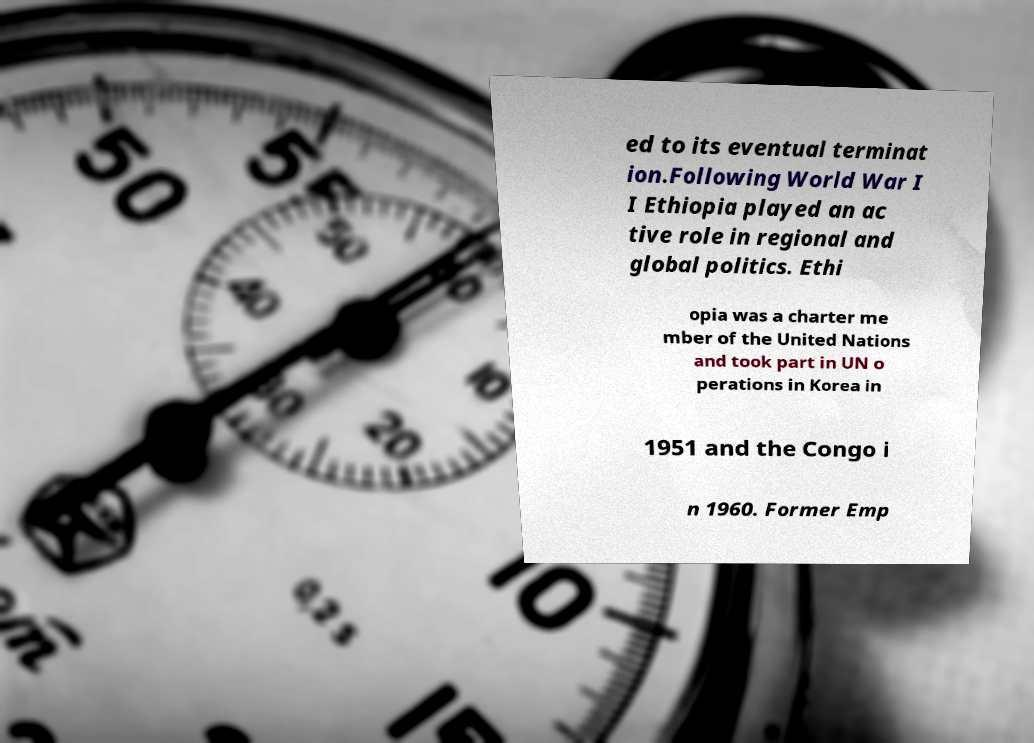I need the written content from this picture converted into text. Can you do that? ed to its eventual terminat ion.Following World War I I Ethiopia played an ac tive role in regional and global politics. Ethi opia was a charter me mber of the United Nations and took part in UN o perations in Korea in 1951 and the Congo i n 1960. Former Emp 